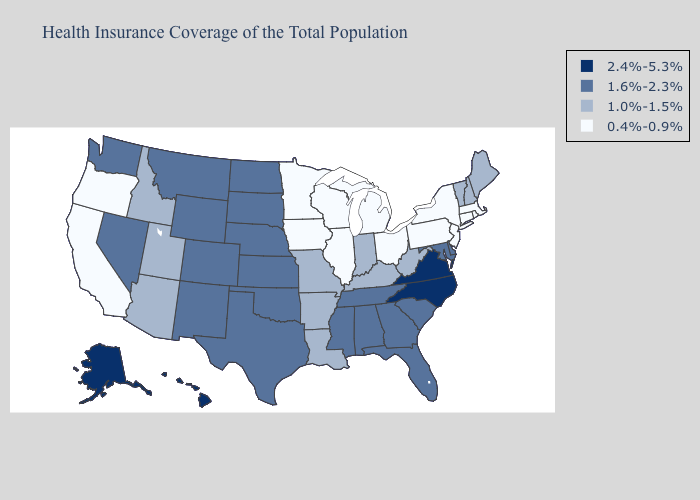What is the value of Kansas?
Give a very brief answer. 1.6%-2.3%. What is the value of Minnesota?
Keep it brief. 0.4%-0.9%. Name the states that have a value in the range 1.0%-1.5%?
Be succinct. Arizona, Arkansas, Idaho, Indiana, Kentucky, Louisiana, Maine, Missouri, New Hampshire, Utah, Vermont, West Virginia. Name the states that have a value in the range 1.0%-1.5%?
Quick response, please. Arizona, Arkansas, Idaho, Indiana, Kentucky, Louisiana, Maine, Missouri, New Hampshire, Utah, Vermont, West Virginia. Does Iowa have the lowest value in the USA?
Quick response, please. Yes. How many symbols are there in the legend?
Quick response, please. 4. Which states have the lowest value in the USA?
Short answer required. California, Connecticut, Illinois, Iowa, Massachusetts, Michigan, Minnesota, New Jersey, New York, Ohio, Oregon, Pennsylvania, Rhode Island, Wisconsin. What is the value of South Carolina?
Quick response, please. 1.6%-2.3%. How many symbols are there in the legend?
Be succinct. 4. Does Iowa have the highest value in the USA?
Quick response, please. No. Does Hawaii have the highest value in the USA?
Be succinct. Yes. Does Idaho have the lowest value in the USA?
Quick response, please. No. Does Oklahoma have the highest value in the USA?
Short answer required. No. What is the value of Mississippi?
Be succinct. 1.6%-2.3%. 